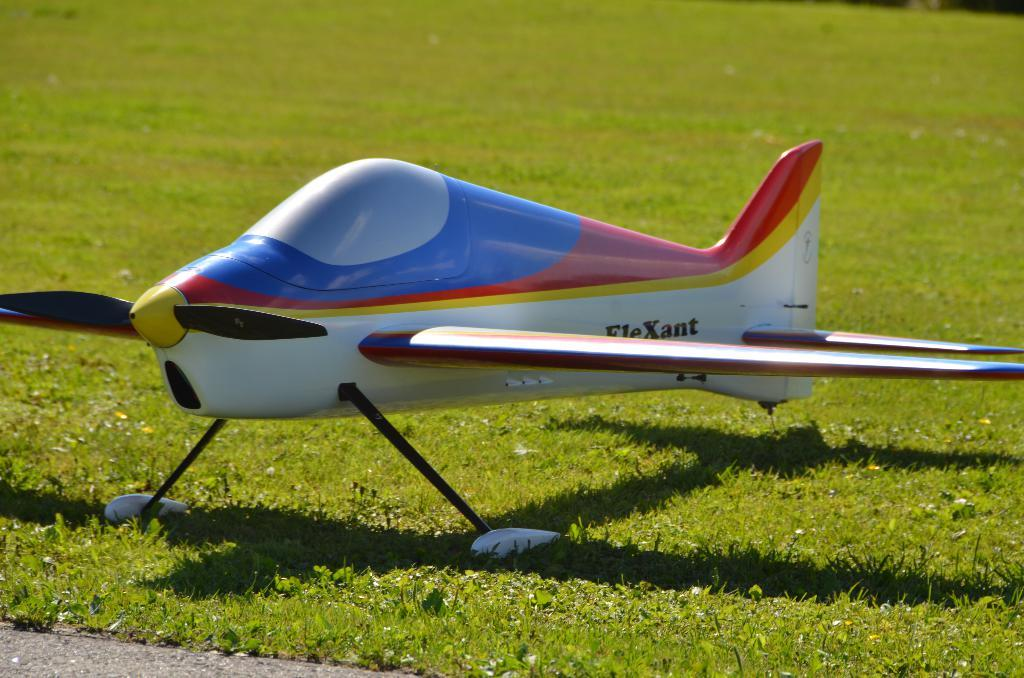What is the main subject of the image? The main subject of the image is an aircraft. What can be seen in the background of the image? There is grass visible in the background of the image. Is there any indication of a path or walkway in the image? Yes, there is a path visible in the image. How does the aircraft show respect to the chalk in the image? There is no chalk present in the image, and therefore no interaction between the aircraft and chalk can be observed. 